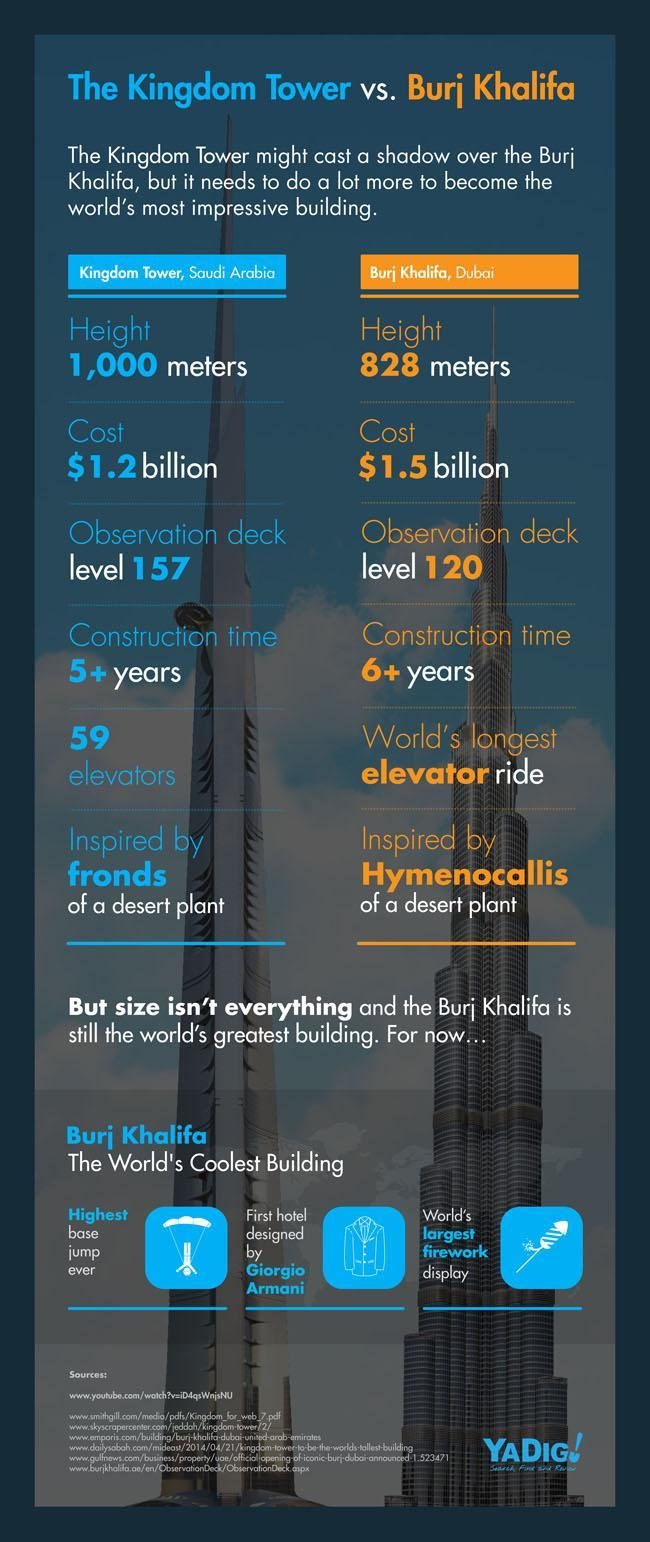How many years did it take for the construction of Kingdom Tower?
Answer the question with a short phrase. 5+ years Which building's design was inspired by Hymenocallis of a desert plant? Burj Khalifa, Dubai Which of the two buildings has 59 elevators in it? Kingdom tower At which level is the observation deck in Kingdom Tower? level 157 What was the construction cost of the Burj Khalifa? 1.5 billion Which building's design was inspired by fronds of a desert plant? Kingdom tower How many years did it take for the construction of Burj Khalifa? 6+ years The hotel designed by which famous fashion designer is housed inside the Burj Khalifa? Giorgio Armani At which level is the observation deck in Burj Khalifa? level 120 Which building is 828 meters high? Burj Khalifa, Dubai 